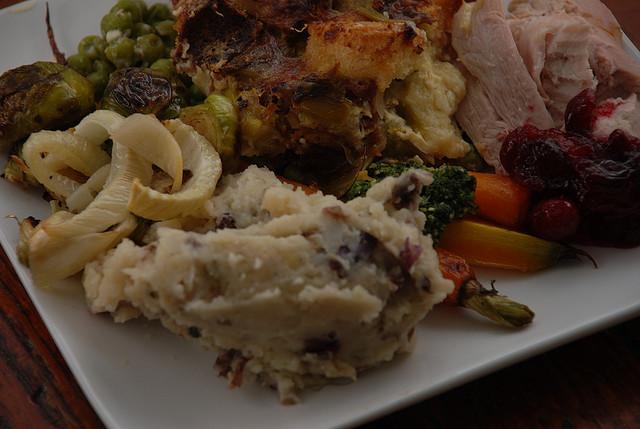What is the orange vegetable?
Short answer required. Carrot. Is a vegetable on the plate?
Answer briefly. Yes. What is the white food?
Give a very brief answer. Mashed potatoes. What is the white thing called on the plate?
Write a very short answer. Mashed potato. Is this a vegetarian dish?
Answer briefly. No. Is this food good for a vegetarian?
Answer briefly. No. What kind of vegetables are there?
Quick response, please. Potatoes onions peppers peas broccoli. What is the shape of the plate?
Keep it brief. Square. What kind of meat is this?
Concise answer only. Ham. Is this food good?
Write a very short answer. Yes. What kind of food is this?
Quick response, please. Mashed potatoes. What are the white vegetables?
Concise answer only. Onions. What is next to the chicken?
Concise answer only. Vegetables. Which food on the plate has the most protein?
Keep it brief. Chicken. Would this be eaten for breakfast?
Quick response, please. No. Is this food in a skillet?
Write a very short answer. No. Is this a pasta dish?
Quick response, please. No. Is this food healthy?
Concise answer only. No. Is this salty?
Short answer required. Yes. What color is the dish the food is being served on?
Short answer required. White. Is there pepper on the onion ring?
Short answer required. No. 